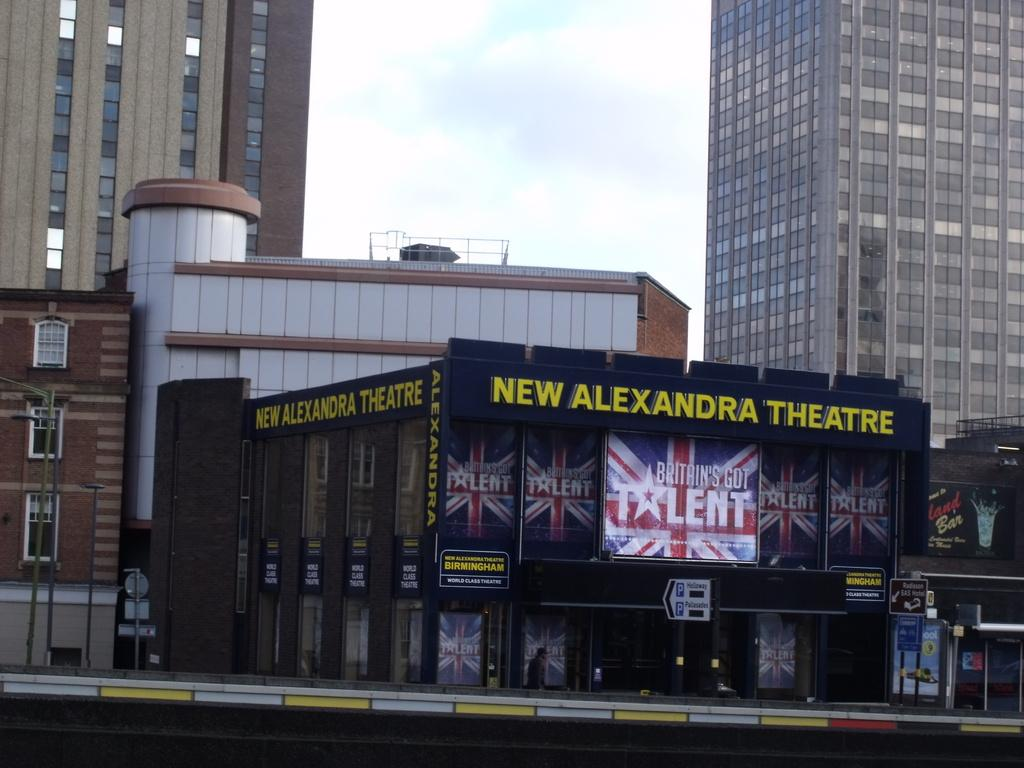What type of structures are present in the image? There is a group of buildings in the image. Can you identify any specific building in the image? Yes, the phrase "New Alexandra Theater" is written on one of the buildings. What can be seen in the background of the image? There is sky visible in the background of the image. What type of honey is being used to clean the tooth in the image? There is no honey or tooth present in the image; it only features a group of buildings and the sky in the background. 